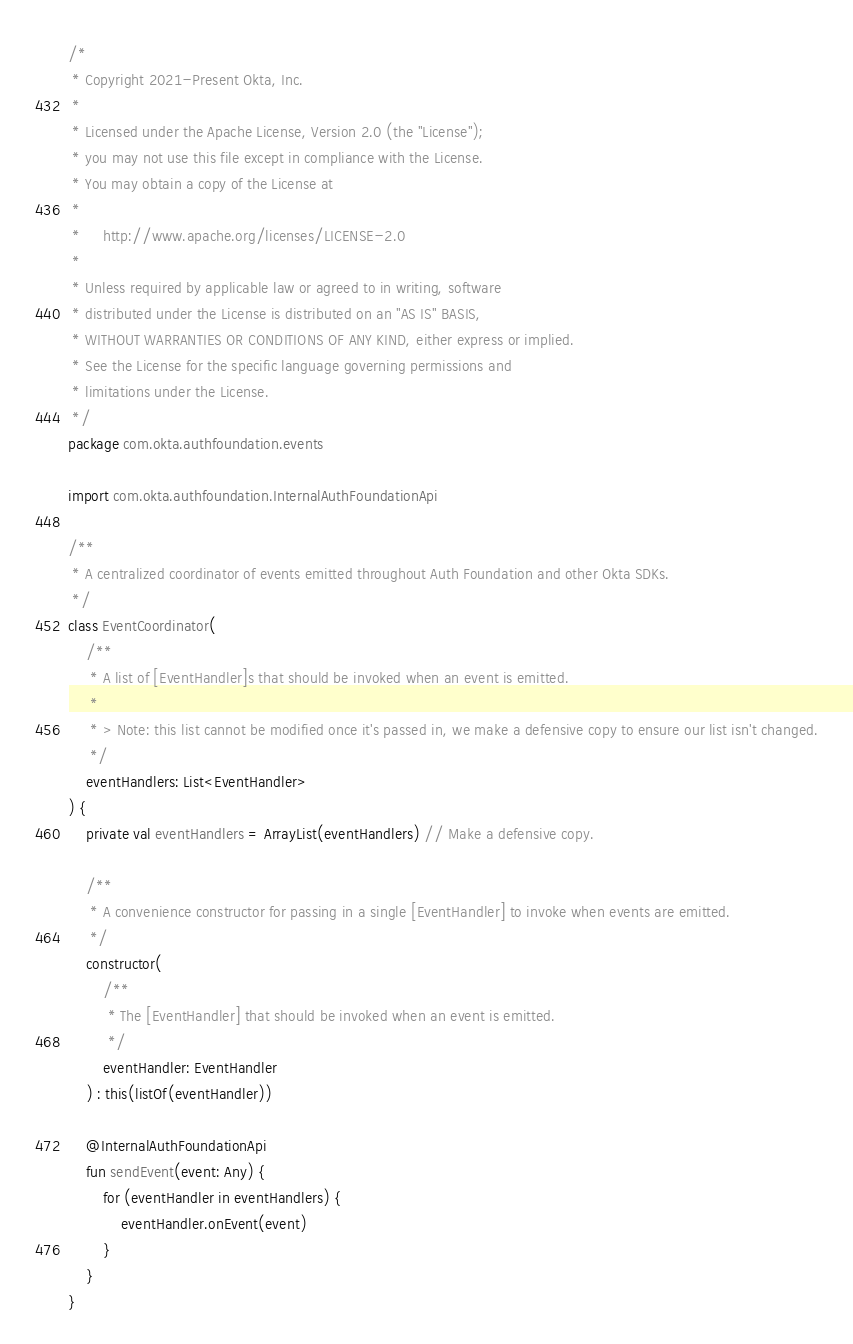Convert code to text. <code><loc_0><loc_0><loc_500><loc_500><_Kotlin_>/*
 * Copyright 2021-Present Okta, Inc.
 *
 * Licensed under the Apache License, Version 2.0 (the "License");
 * you may not use this file except in compliance with the License.
 * You may obtain a copy of the License at
 *
 *     http://www.apache.org/licenses/LICENSE-2.0
 *
 * Unless required by applicable law or agreed to in writing, software
 * distributed under the License is distributed on an "AS IS" BASIS,
 * WITHOUT WARRANTIES OR CONDITIONS OF ANY KIND, either express or implied.
 * See the License for the specific language governing permissions and
 * limitations under the License.
 */
package com.okta.authfoundation.events

import com.okta.authfoundation.InternalAuthFoundationApi

/**
 * A centralized coordinator of events emitted throughout Auth Foundation and other Okta SDKs.
 */
class EventCoordinator(
    /**
     * A list of [EventHandler]s that should be invoked when an event is emitted.
     *
     * > Note: this list cannot be modified once it's passed in, we make a defensive copy to ensure our list isn't changed.
     */
    eventHandlers: List<EventHandler>
) {
    private val eventHandlers = ArrayList(eventHandlers) // Make a defensive copy.

    /**
     * A convenience constructor for passing in a single [EventHandler] to invoke when events are emitted.
     */
    constructor(
        /**
         * The [EventHandler] that should be invoked when an event is emitted.
         */
        eventHandler: EventHandler
    ) : this(listOf(eventHandler))

    @InternalAuthFoundationApi
    fun sendEvent(event: Any) {
        for (eventHandler in eventHandlers) {
            eventHandler.onEvent(event)
        }
    }
}
</code> 